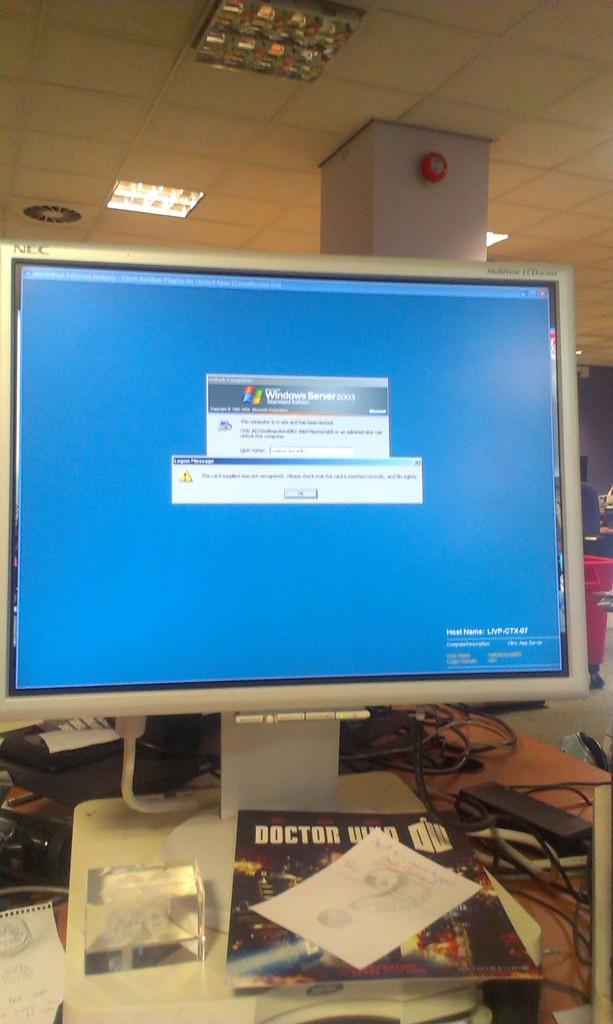Does this computer use the windows operating system?
Your answer should be very brief. Yes. What word is visable on the magazine cover?
Keep it short and to the point. Doctor. 